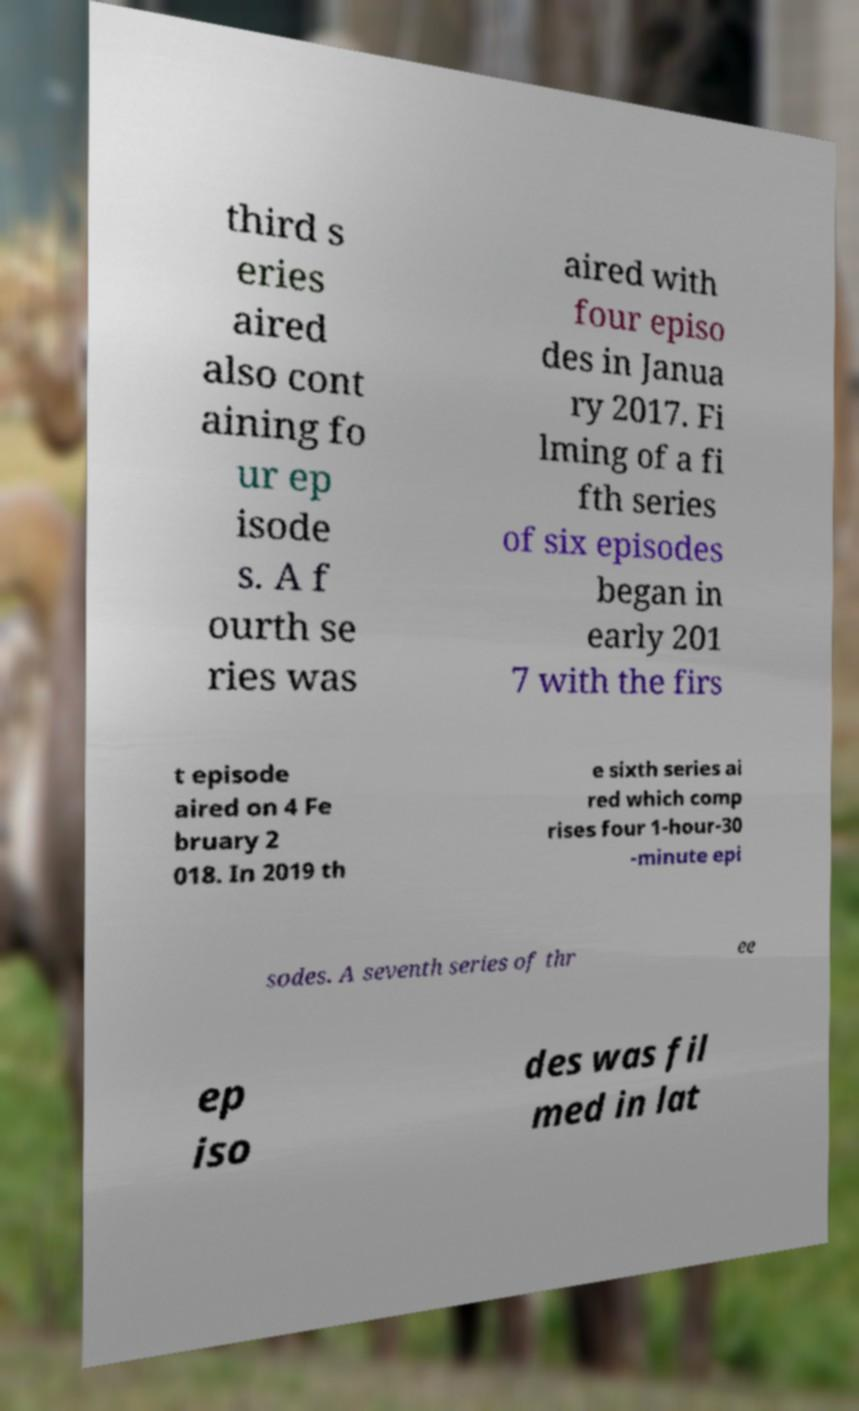What messages or text are displayed in this image? I need them in a readable, typed format. third s eries aired also cont aining fo ur ep isode s. A f ourth se ries was aired with four episo des in Janua ry 2017. Fi lming of a fi fth series of six episodes began in early 201 7 with the firs t episode aired on 4 Fe bruary 2 018. In 2019 th e sixth series ai red which comp rises four 1-hour-30 -minute epi sodes. A seventh series of thr ee ep iso des was fil med in lat 